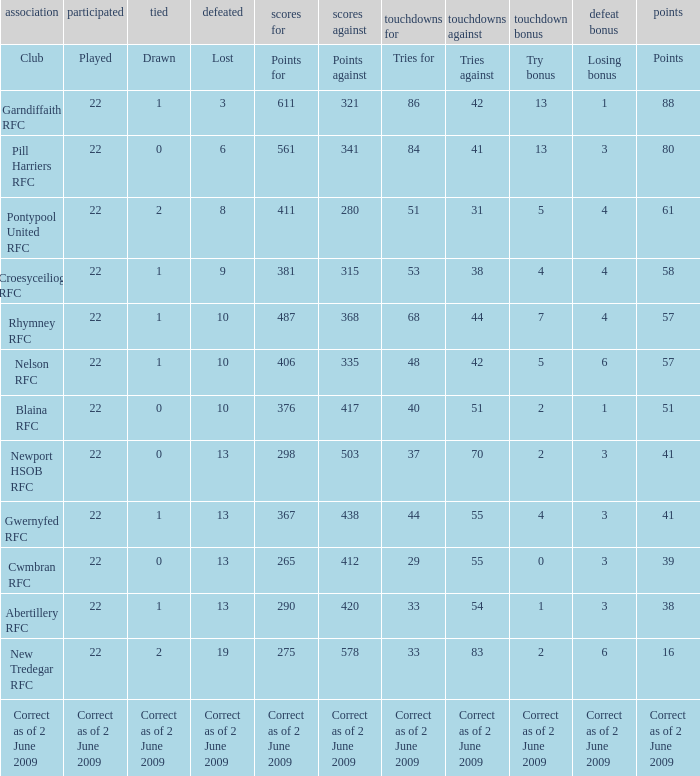Which club has 275 points? New Tredegar RFC. 